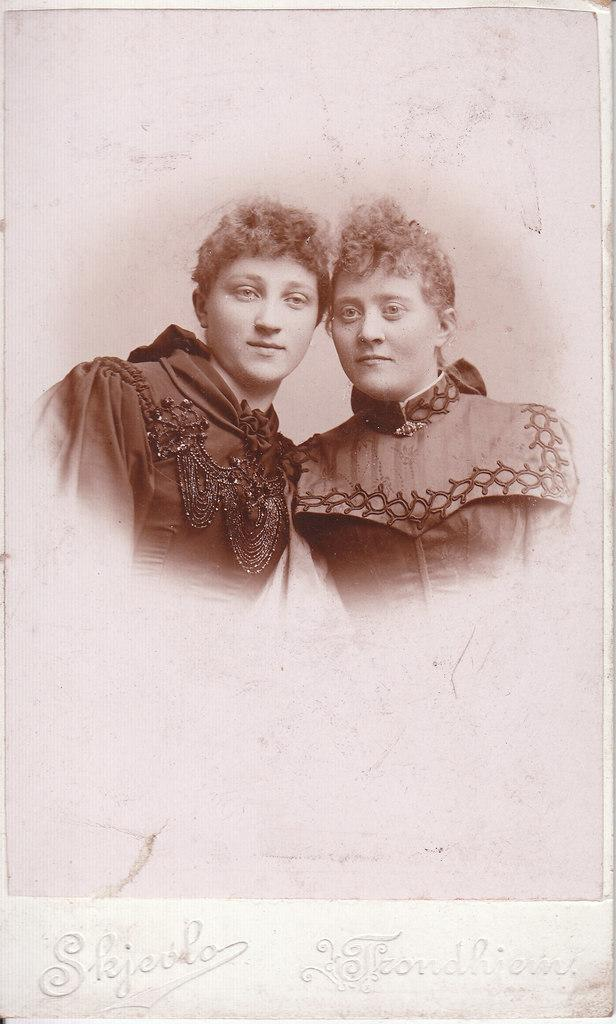What is depicted in the image? There is a picture of two persons in the image. Can you describe any additional details about the image? Text is written at the bottom of the image. What type of waves can be seen crashing on the edge in the image? There are no waves or edges present in the image; it features a picture of two persons with text at the bottom. 